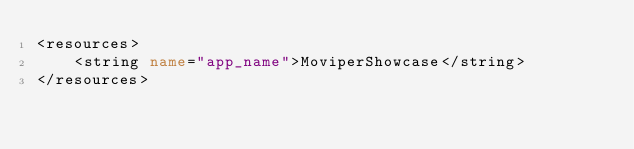<code> <loc_0><loc_0><loc_500><loc_500><_XML_><resources>
    <string name="app_name">MoviperShowcase</string>
</resources>
</code> 